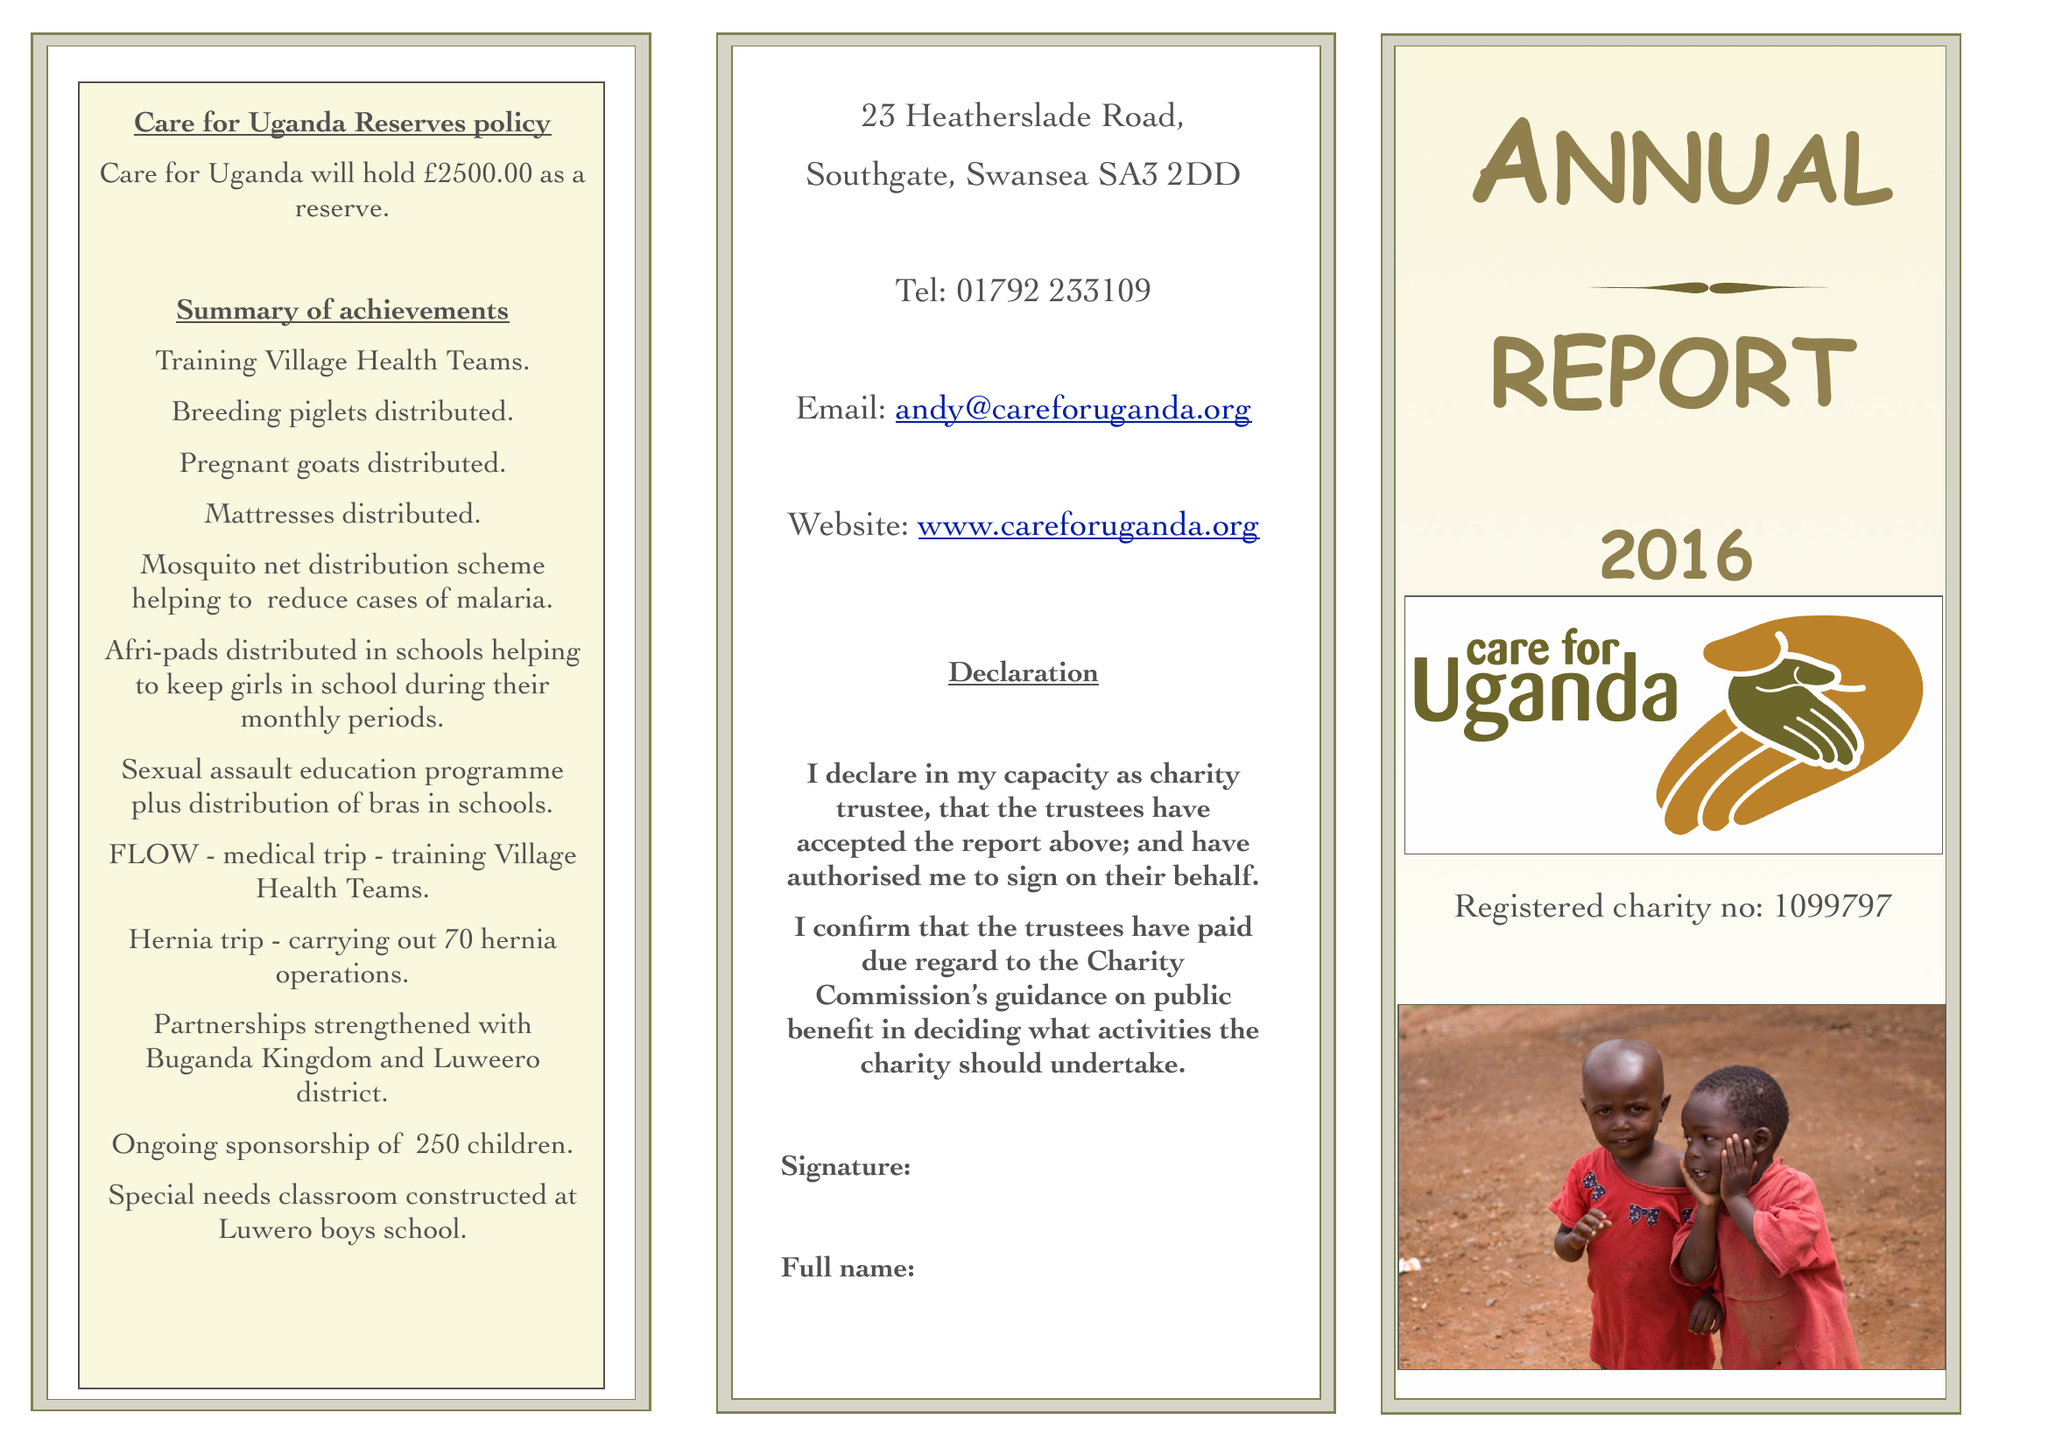What is the value for the address__postcode?
Answer the question using a single word or phrase. SA3 2DD 